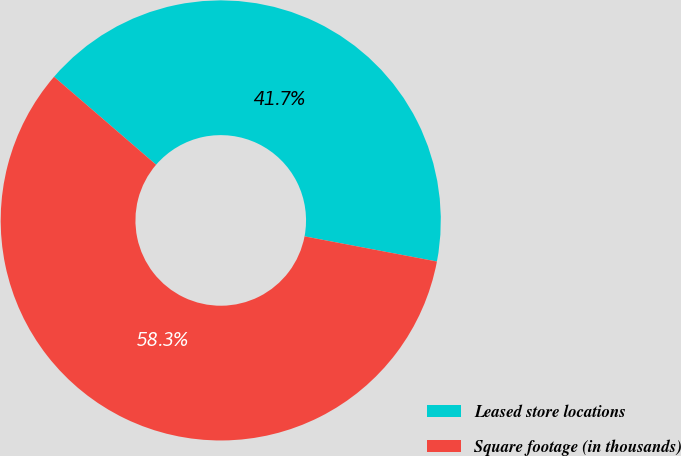Convert chart to OTSL. <chart><loc_0><loc_0><loc_500><loc_500><pie_chart><fcel>Leased store locations<fcel>Square footage (in thousands)<nl><fcel>41.67%<fcel>58.33%<nl></chart> 